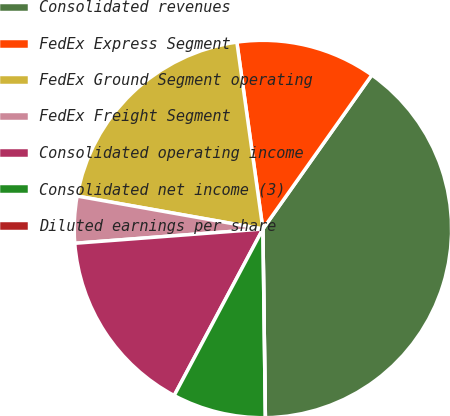<chart> <loc_0><loc_0><loc_500><loc_500><pie_chart><fcel>Consolidated revenues<fcel>FedEx Express Segment<fcel>FedEx Ground Segment operating<fcel>FedEx Freight Segment<fcel>Consolidated operating income<fcel>Consolidated net income (3)<fcel>Diluted earnings per share<nl><fcel>39.99%<fcel>12.0%<fcel>20.0%<fcel>4.0%<fcel>16.0%<fcel>8.0%<fcel>0.0%<nl></chart> 